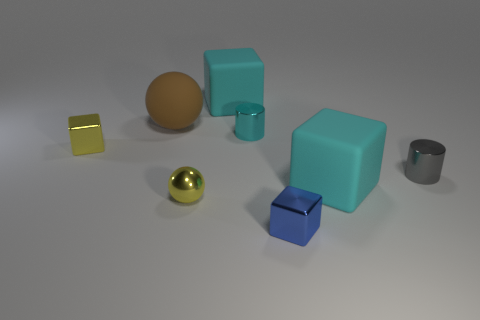What is the material of the tiny yellow object that is the same shape as the blue object?
Ensure brevity in your answer.  Metal. Are there any large cyan matte things that are left of the large matte cube left of the small metal cylinder that is to the left of the small blue metal block?
Provide a short and direct response. No. What number of other objects are the same color as the tiny ball?
Your answer should be very brief. 1. What number of cubes are in front of the cyan cylinder and to the left of the tiny cyan thing?
Give a very brief answer. 1. There is a brown matte thing; what shape is it?
Keep it short and to the point. Sphere. How many other objects are there of the same material as the gray thing?
Your answer should be compact. 4. There is a tiny metal cube in front of the large cyan rubber object in front of the tiny metallic cylinder to the right of the small cyan metal object; what is its color?
Offer a very short reply. Blue. There is a blue thing that is the same size as the yellow shiny cube; what is its material?
Your response must be concise. Metal. How many things are shiny blocks on the right side of the tiny cyan cylinder or small shiny objects?
Ensure brevity in your answer.  5. Are there any cubes?
Your response must be concise. Yes. 